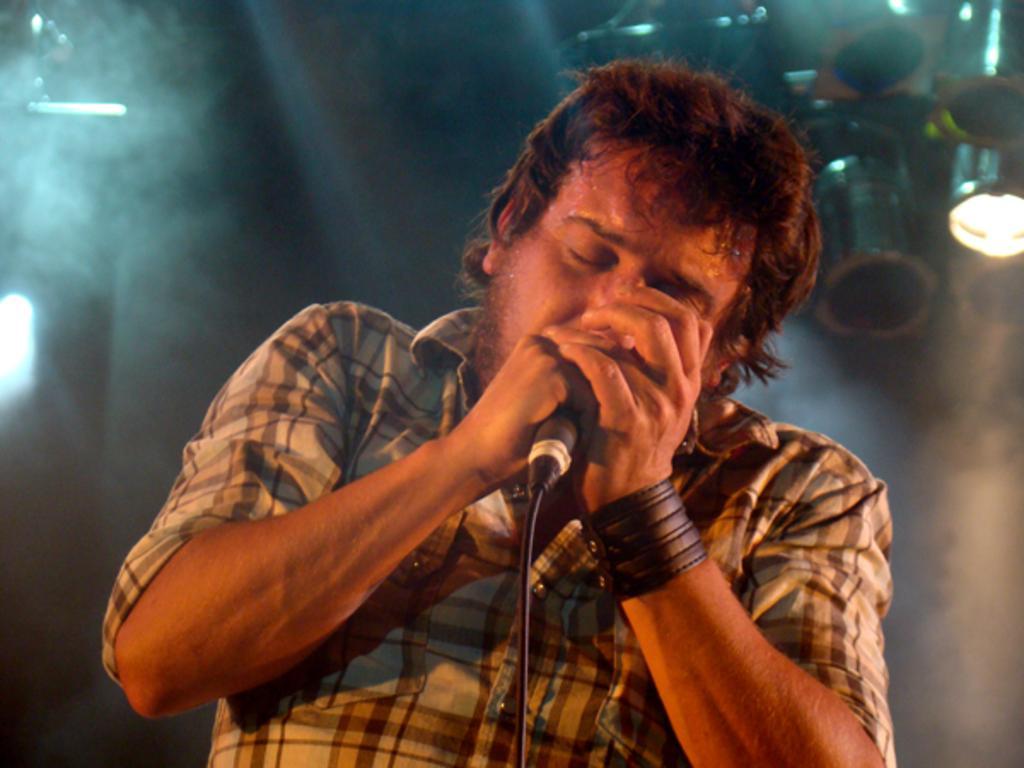Could you give a brief overview of what you see in this image? Background is dark and smoky. We can see lights here. In Front of a picture we can see one man wearing a wrist band, holding a mike in his hand and singing. 